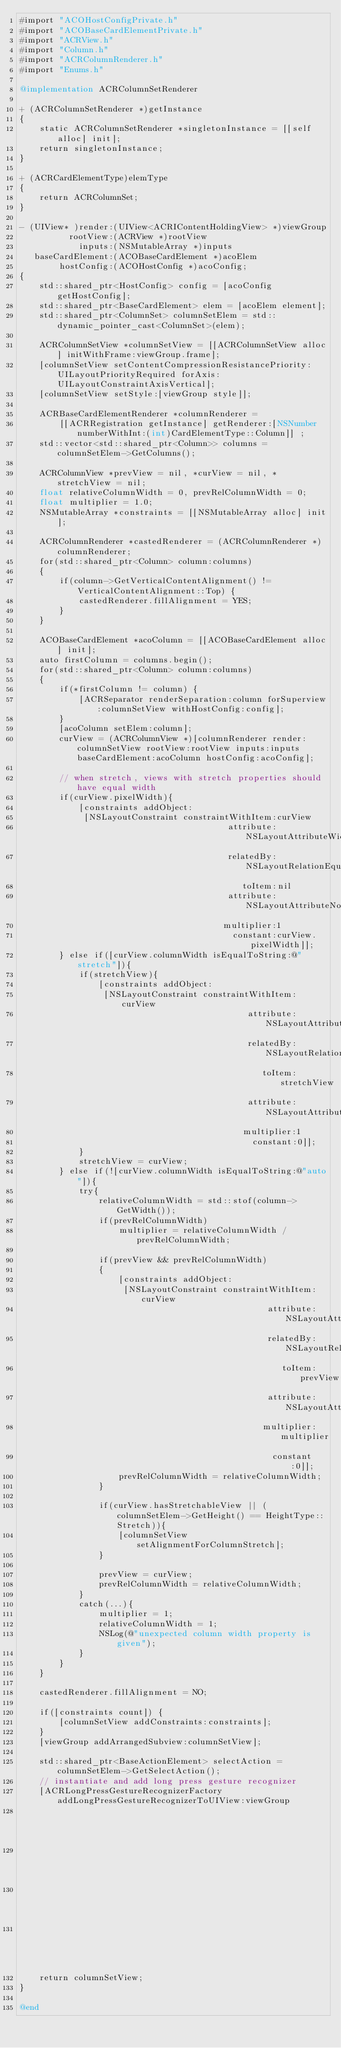<code> <loc_0><loc_0><loc_500><loc_500><_ObjectiveC_>#import "ACOHostConfigPrivate.h"
#import "ACOBaseCardElementPrivate.h"
#import "ACRView.h"
#import "Column.h"
#import "ACRColumnRenderer.h"
#import "Enums.h"

@implementation ACRColumnSetRenderer

+ (ACRColumnSetRenderer *)getInstance
{
    static ACRColumnSetRenderer *singletonInstance = [[self alloc] init];
    return singletonInstance;
}

+ (ACRCardElementType)elemType
{
    return ACRColumnSet;
}

- (UIView* )render:(UIView<ACRIContentHoldingView> *)viewGroup
          rootView:(ACRView *)rootView
            inputs:(NSMutableArray *)inputs
   baseCardElement:(ACOBaseCardElement *)acoElem
        hostConfig:(ACOHostConfig *)acoConfig;
{
    std::shared_ptr<HostConfig> config = [acoConfig getHostConfig];
    std::shared_ptr<BaseCardElement> elem = [acoElem element];
    std::shared_ptr<ColumnSet> columnSetElem = std::dynamic_pointer_cast<ColumnSet>(elem);

    ACRColumnSetView *columnSetView = [[ACRColumnSetView alloc] initWithFrame:viewGroup.frame];
    [columnSetView setContentCompressionResistancePriority:UILayoutPriorityRequired forAxis:UILayoutConstraintAxisVertical];
    [columnSetView setStyle:[viewGroup style]];

    ACRBaseCardElementRenderer *columnRenderer =
        [[ACRRegistration getInstance] getRenderer:[NSNumber numberWithInt:(int)CardElementType::Column]] ;
    std::vector<std::shared_ptr<Column>> columns = columnSetElem->GetColumns();

    ACRColumnView *prevView = nil, *curView = nil, *stretchView = nil;
    float relativeColumnWidth = 0, prevRelColumnWidth = 0;
    float multiplier = 1.0;
    NSMutableArray *constraints = [[NSMutableArray alloc] init];

    ACRColumnRenderer *castedRenderer = (ACRColumnRenderer *)columnRenderer;
    for(std::shared_ptr<Column> column:columns)
    {
        if(column->GetVerticalContentAlignment() != VerticalContentAlignment::Top) {
            castedRenderer.fillAlignment = YES;
        }
    }

    ACOBaseCardElement *acoColumn = [[ACOBaseCardElement alloc] init];
    auto firstColumn = columns.begin();
    for(std::shared_ptr<Column> column:columns)
    {
        if(*firstColumn != column) {
            [ACRSeparator renderSeparation:column forSuperview:columnSetView withHostConfig:config];
        }
        [acoColumn setElem:column];
        curView = (ACRColumnView *)[columnRenderer render:columnSetView rootView:rootView inputs:inputs baseCardElement:acoColumn hostConfig:acoConfig];

        // when stretch, views with stretch properties should have equal width
        if(curView.pixelWidth){
            [constraints addObject:
             [NSLayoutConstraint constraintWithItem:curView
                                          attribute:NSLayoutAttributeWidth
                                          relatedBy:NSLayoutRelationEqual
                                             toItem:nil
                                          attribute:NSLayoutAttributeNotAnAttribute
                                         multiplier:1
                                           constant:curView.pixelWidth]];
        } else if([curView.columnWidth isEqualToString:@"stretch"]){
            if(stretchView){
                [constraints addObject:
                 [NSLayoutConstraint constraintWithItem:curView
                                              attribute:NSLayoutAttributeWidth
                                              relatedBy:NSLayoutRelationEqual
                                                 toItem:stretchView
                                              attribute:NSLayoutAttributeWidth
                                             multiplier:1
                                               constant:0]];
            }
            stretchView = curView;
        } else if(![curView.columnWidth isEqualToString:@"auto"]){
            try{
                relativeColumnWidth = std::stof(column->GetWidth());
                if(prevRelColumnWidth)
                    multiplier = relativeColumnWidth / prevRelColumnWidth;

                if(prevView && prevRelColumnWidth)
                {
                    [constraints addObject:
                     [NSLayoutConstraint constraintWithItem:curView
                                                  attribute:NSLayoutAttributeWidth
                                                  relatedBy:NSLayoutRelationEqual
                                                     toItem:prevView
                                                  attribute:NSLayoutAttributeWidth
                                                 multiplier:multiplier
                                                   constant:0]];
                    prevRelColumnWidth = relativeColumnWidth;
                }

                if(curView.hasStretchableView || (columnSetElem->GetHeight() == HeightType::Stretch)){
                    [columnSetView setAlignmentForColumnStretch];
                }

                prevView = curView;
                prevRelColumnWidth = relativeColumnWidth;
            }
            catch(...){
                multiplier = 1;
                relativeColumnWidth = 1;
                NSLog(@"unexpected column width property is given");
            }
        }
    }

    castedRenderer.fillAlignment = NO;

    if([constraints count]) {
        [columnSetView addConstraints:constraints];
    }
    [viewGroup addArrangedSubview:columnSetView];

    std::shared_ptr<BaseActionElement> selectAction = columnSetElem->GetSelectAction();
    // instantiate and add long press gesture recognizer
    [ACRLongPressGestureRecognizerFactory addLongPressGestureRecognizerToUIView:viewGroup
                                                                       rootView:rootView
                                                                  recipientView:columnSetView
                                                                  actionElement:selectAction
                                                                     hostConfig:acoConfig];
    return columnSetView;
}

@end
</code> 